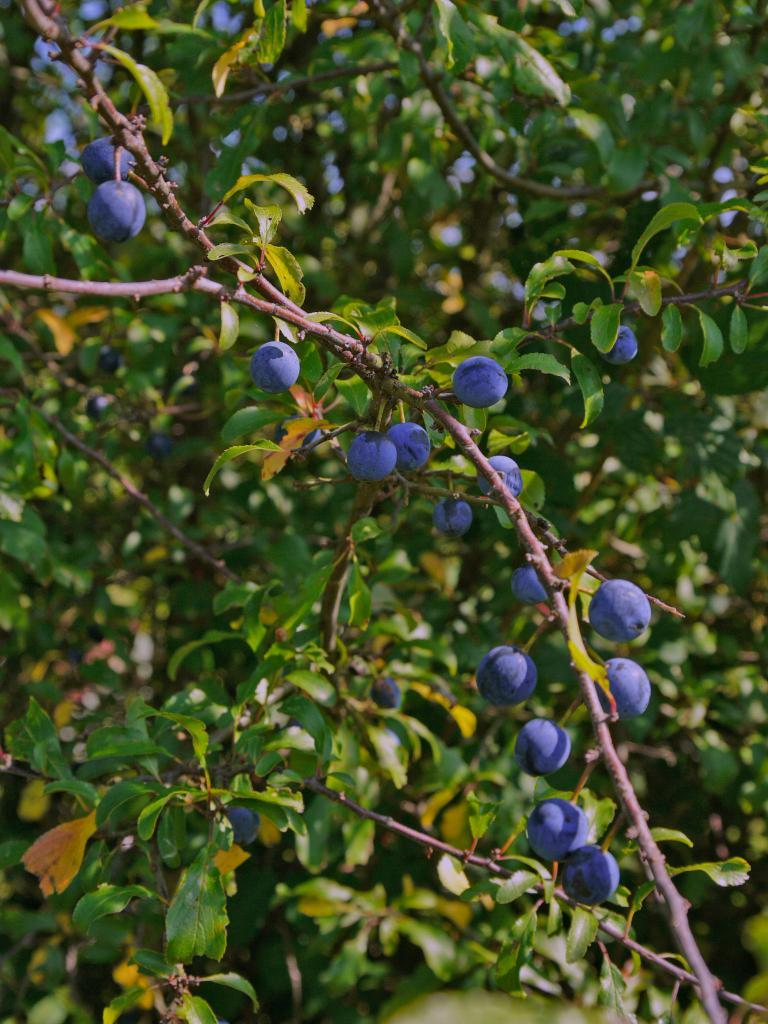What type of plants are visible in the image? There are plants with flowers in the image. What can be seen in the background of the image? There are trees in the background of the image. How much does the beggar weigh in the image? There is no beggar present in the image. What mathematical operation can be performed on the flowers in the image? The flowers in the image are not related to mathematical operations, such as addition. 